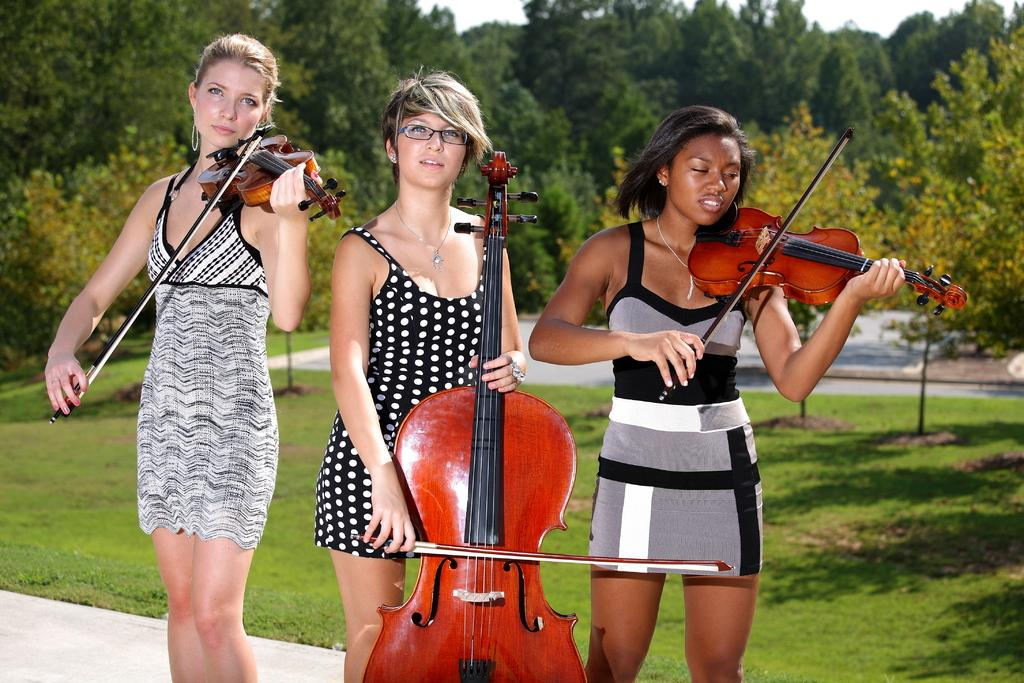What type of vegetation can be seen in the background of the image? There are trees in the background of the image. What is the color and texture of the grass in the image? The grass in the image is fresh and green. What other types of plants are visible in the image? There are plants in the image. How many women are present in the image, and what are they doing? There are three women standing in the image, and they are playing violins. What type of appliance can be seen in the image? There is no appliance present in the image. Is there an oven visible in the image? No, there is no oven present in the image. 